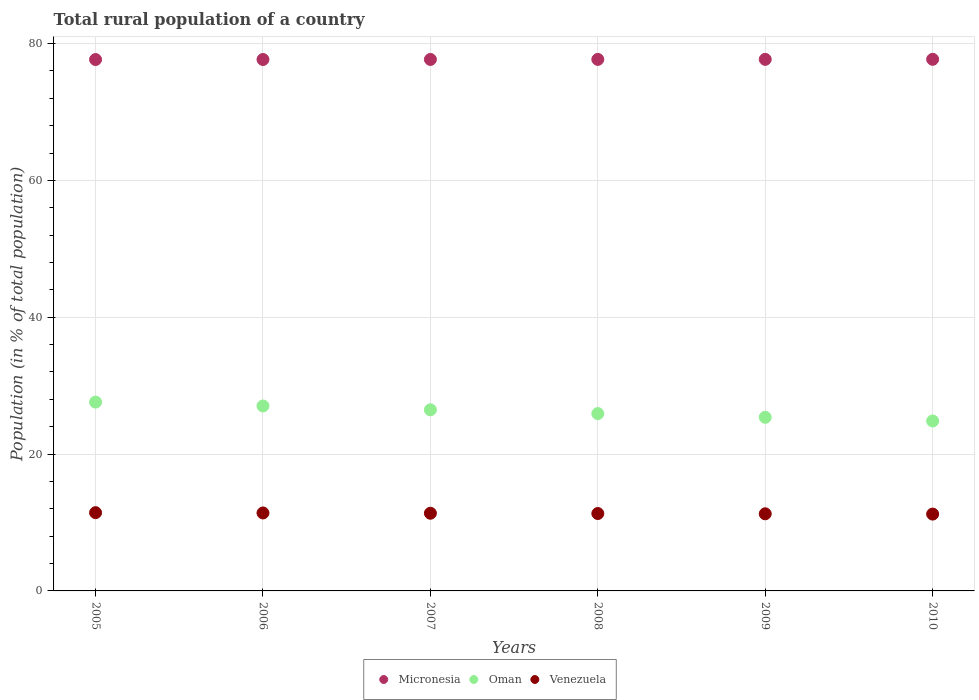How many different coloured dotlines are there?
Give a very brief answer. 3. What is the rural population in Micronesia in 2005?
Provide a succinct answer. 77.67. Across all years, what is the maximum rural population in Micronesia?
Provide a short and direct response. 77.7. Across all years, what is the minimum rural population in Venezuela?
Provide a succinct answer. 11.23. In which year was the rural population in Oman maximum?
Offer a terse response. 2005. In which year was the rural population in Venezuela minimum?
Give a very brief answer. 2010. What is the total rural population in Micronesia in the graph?
Give a very brief answer. 466.11. What is the difference between the rural population in Micronesia in 2005 and that in 2006?
Make the answer very short. -0.01. What is the difference between the rural population in Micronesia in 2007 and the rural population in Oman in 2010?
Keep it short and to the point. 52.84. What is the average rural population in Oman per year?
Your answer should be very brief. 26.21. In the year 2005, what is the difference between the rural population in Micronesia and rural population in Venezuela?
Offer a terse response. 66.23. What is the ratio of the rural population in Venezuela in 2006 to that in 2009?
Provide a short and direct response. 1.01. Is the rural population in Oman in 2007 less than that in 2009?
Your response must be concise. No. Is the difference between the rural population in Micronesia in 2005 and 2007 greater than the difference between the rural population in Venezuela in 2005 and 2007?
Make the answer very short. No. What is the difference between the highest and the second highest rural population in Micronesia?
Ensure brevity in your answer.  0.01. What is the difference between the highest and the lowest rural population in Venezuela?
Ensure brevity in your answer.  0.21. In how many years, is the rural population in Micronesia greater than the average rural population in Micronesia taken over all years?
Provide a succinct answer. 3. Is the sum of the rural population in Oman in 2005 and 2009 greater than the maximum rural population in Micronesia across all years?
Offer a very short reply. No. Does the rural population in Oman monotonically increase over the years?
Your answer should be very brief. No. Is the rural population in Micronesia strictly less than the rural population in Oman over the years?
Your answer should be compact. No. What is the difference between two consecutive major ticks on the Y-axis?
Offer a very short reply. 20. Does the graph contain any zero values?
Give a very brief answer. No. Does the graph contain grids?
Ensure brevity in your answer.  Yes. Where does the legend appear in the graph?
Your response must be concise. Bottom center. How many legend labels are there?
Keep it short and to the point. 3. What is the title of the graph?
Offer a terse response. Total rural population of a country. Does "Papua New Guinea" appear as one of the legend labels in the graph?
Your answer should be very brief. No. What is the label or title of the X-axis?
Your answer should be very brief. Years. What is the label or title of the Y-axis?
Your answer should be very brief. Population (in % of total population). What is the Population (in % of total population) in Micronesia in 2005?
Your answer should be very brief. 77.67. What is the Population (in % of total population) in Oman in 2005?
Make the answer very short. 27.6. What is the Population (in % of total population) of Venezuela in 2005?
Provide a short and direct response. 11.44. What is the Population (in % of total population) in Micronesia in 2006?
Offer a terse response. 77.68. What is the Population (in % of total population) of Oman in 2006?
Your answer should be very brief. 27.03. What is the Population (in % of total population) in Venezuela in 2006?
Your response must be concise. 11.39. What is the Population (in % of total population) in Micronesia in 2007?
Give a very brief answer. 77.68. What is the Population (in % of total population) in Oman in 2007?
Offer a very short reply. 26.47. What is the Population (in % of total population) of Venezuela in 2007?
Give a very brief answer. 11.35. What is the Population (in % of total population) of Micronesia in 2008?
Your response must be concise. 77.69. What is the Population (in % of total population) of Oman in 2008?
Your answer should be very brief. 25.92. What is the Population (in % of total population) in Venezuela in 2008?
Your answer should be compact. 11.31. What is the Population (in % of total population) in Micronesia in 2009?
Provide a short and direct response. 77.69. What is the Population (in % of total population) in Oman in 2009?
Keep it short and to the point. 25.38. What is the Population (in % of total population) in Venezuela in 2009?
Ensure brevity in your answer.  11.27. What is the Population (in % of total population) in Micronesia in 2010?
Your response must be concise. 77.7. What is the Population (in % of total population) of Oman in 2010?
Give a very brief answer. 24.84. What is the Population (in % of total population) of Venezuela in 2010?
Provide a short and direct response. 11.23. Across all years, what is the maximum Population (in % of total population) of Micronesia?
Offer a terse response. 77.7. Across all years, what is the maximum Population (in % of total population) of Oman?
Ensure brevity in your answer.  27.6. Across all years, what is the maximum Population (in % of total population) in Venezuela?
Provide a succinct answer. 11.44. Across all years, what is the minimum Population (in % of total population) of Micronesia?
Your response must be concise. 77.67. Across all years, what is the minimum Population (in % of total population) of Oman?
Provide a succinct answer. 24.84. Across all years, what is the minimum Population (in % of total population) in Venezuela?
Offer a very short reply. 11.23. What is the total Population (in % of total population) in Micronesia in the graph?
Ensure brevity in your answer.  466.12. What is the total Population (in % of total population) in Oman in the graph?
Offer a terse response. 157.24. What is the total Population (in % of total population) in Venezuela in the graph?
Your response must be concise. 68. What is the difference between the Population (in % of total population) in Micronesia in 2005 and that in 2006?
Provide a succinct answer. -0.01. What is the difference between the Population (in % of total population) of Oman in 2005 and that in 2006?
Offer a terse response. 0.57. What is the difference between the Population (in % of total population) in Venezuela in 2005 and that in 2006?
Give a very brief answer. 0.04. What is the difference between the Population (in % of total population) in Micronesia in 2005 and that in 2007?
Ensure brevity in your answer.  -0.01. What is the difference between the Population (in % of total population) of Oman in 2005 and that in 2007?
Keep it short and to the point. 1.13. What is the difference between the Population (in % of total population) of Venezuela in 2005 and that in 2007?
Your response must be concise. 0.08. What is the difference between the Population (in % of total population) in Micronesia in 2005 and that in 2008?
Offer a terse response. -0.02. What is the difference between the Population (in % of total population) of Oman in 2005 and that in 2008?
Offer a terse response. 1.68. What is the difference between the Population (in % of total population) in Venezuela in 2005 and that in 2008?
Provide a short and direct response. 0.12. What is the difference between the Population (in % of total population) in Micronesia in 2005 and that in 2009?
Ensure brevity in your answer.  -0.03. What is the difference between the Population (in % of total population) of Oman in 2005 and that in 2009?
Ensure brevity in your answer.  2.22. What is the difference between the Population (in % of total population) in Venezuela in 2005 and that in 2009?
Make the answer very short. 0.17. What is the difference between the Population (in % of total population) in Micronesia in 2005 and that in 2010?
Provide a succinct answer. -0.03. What is the difference between the Population (in % of total population) in Oman in 2005 and that in 2010?
Your answer should be very brief. 2.76. What is the difference between the Population (in % of total population) in Venezuela in 2005 and that in 2010?
Ensure brevity in your answer.  0.21. What is the difference between the Population (in % of total population) in Micronesia in 2006 and that in 2007?
Provide a short and direct response. -0.01. What is the difference between the Population (in % of total population) of Oman in 2006 and that in 2007?
Provide a succinct answer. 0.56. What is the difference between the Population (in % of total population) of Venezuela in 2006 and that in 2007?
Offer a terse response. 0.04. What is the difference between the Population (in % of total population) of Micronesia in 2006 and that in 2008?
Your answer should be compact. -0.01. What is the difference between the Population (in % of total population) in Oman in 2006 and that in 2008?
Give a very brief answer. 1.11. What is the difference between the Population (in % of total population) of Venezuela in 2006 and that in 2008?
Give a very brief answer. 0.08. What is the difference between the Population (in % of total population) in Micronesia in 2006 and that in 2009?
Offer a terse response. -0.02. What is the difference between the Population (in % of total population) of Oman in 2006 and that in 2009?
Offer a very short reply. 1.66. What is the difference between the Population (in % of total population) of Venezuela in 2006 and that in 2009?
Your answer should be very brief. 0.12. What is the difference between the Population (in % of total population) in Micronesia in 2006 and that in 2010?
Give a very brief answer. -0.03. What is the difference between the Population (in % of total population) of Oman in 2006 and that in 2010?
Make the answer very short. 2.19. What is the difference between the Population (in % of total population) in Venezuela in 2006 and that in 2010?
Your answer should be compact. 0.16. What is the difference between the Population (in % of total population) in Micronesia in 2007 and that in 2008?
Your response must be concise. -0.01. What is the difference between the Population (in % of total population) of Oman in 2007 and that in 2008?
Offer a very short reply. 0.55. What is the difference between the Population (in % of total population) of Venezuela in 2007 and that in 2008?
Your response must be concise. 0.04. What is the difference between the Population (in % of total population) in Micronesia in 2007 and that in 2009?
Your answer should be very brief. -0.01. What is the difference between the Population (in % of total population) in Oman in 2007 and that in 2009?
Your answer should be compact. 1.1. What is the difference between the Population (in % of total population) in Venezuela in 2007 and that in 2009?
Your response must be concise. 0.08. What is the difference between the Population (in % of total population) of Micronesia in 2007 and that in 2010?
Your response must be concise. -0.02. What is the difference between the Population (in % of total population) of Oman in 2007 and that in 2010?
Keep it short and to the point. 1.63. What is the difference between the Population (in % of total population) of Venezuela in 2007 and that in 2010?
Make the answer very short. 0.12. What is the difference between the Population (in % of total population) of Micronesia in 2008 and that in 2009?
Your response must be concise. -0.01. What is the difference between the Population (in % of total population) of Oman in 2008 and that in 2009?
Offer a very short reply. 0.54. What is the difference between the Population (in % of total population) of Venezuela in 2008 and that in 2009?
Provide a succinct answer. 0.04. What is the difference between the Population (in % of total population) of Micronesia in 2008 and that in 2010?
Provide a short and direct response. -0.01. What is the difference between the Population (in % of total population) of Oman in 2008 and that in 2010?
Keep it short and to the point. 1.08. What is the difference between the Population (in % of total population) in Venezuela in 2008 and that in 2010?
Offer a terse response. 0.08. What is the difference between the Population (in % of total population) in Micronesia in 2009 and that in 2010?
Your answer should be very brief. -0.01. What is the difference between the Population (in % of total population) of Oman in 2009 and that in 2010?
Make the answer very short. 0.54. What is the difference between the Population (in % of total population) in Venezuela in 2009 and that in 2010?
Your response must be concise. 0.04. What is the difference between the Population (in % of total population) in Micronesia in 2005 and the Population (in % of total population) in Oman in 2006?
Provide a succinct answer. 50.64. What is the difference between the Population (in % of total population) of Micronesia in 2005 and the Population (in % of total population) of Venezuela in 2006?
Give a very brief answer. 66.28. What is the difference between the Population (in % of total population) of Oman in 2005 and the Population (in % of total population) of Venezuela in 2006?
Your response must be concise. 16.2. What is the difference between the Population (in % of total population) in Micronesia in 2005 and the Population (in % of total population) in Oman in 2007?
Your answer should be very brief. 51.2. What is the difference between the Population (in % of total population) in Micronesia in 2005 and the Population (in % of total population) in Venezuela in 2007?
Ensure brevity in your answer.  66.32. What is the difference between the Population (in % of total population) in Oman in 2005 and the Population (in % of total population) in Venezuela in 2007?
Your answer should be compact. 16.25. What is the difference between the Population (in % of total population) in Micronesia in 2005 and the Population (in % of total population) in Oman in 2008?
Offer a very short reply. 51.75. What is the difference between the Population (in % of total population) of Micronesia in 2005 and the Population (in % of total population) of Venezuela in 2008?
Offer a very short reply. 66.36. What is the difference between the Population (in % of total population) in Oman in 2005 and the Population (in % of total population) in Venezuela in 2008?
Give a very brief answer. 16.29. What is the difference between the Population (in % of total population) of Micronesia in 2005 and the Population (in % of total population) of Oman in 2009?
Keep it short and to the point. 52.29. What is the difference between the Population (in % of total population) in Micronesia in 2005 and the Population (in % of total population) in Venezuela in 2009?
Your response must be concise. 66.4. What is the difference between the Population (in % of total population) of Oman in 2005 and the Population (in % of total population) of Venezuela in 2009?
Provide a short and direct response. 16.33. What is the difference between the Population (in % of total population) of Micronesia in 2005 and the Population (in % of total population) of Oman in 2010?
Ensure brevity in your answer.  52.83. What is the difference between the Population (in % of total population) of Micronesia in 2005 and the Population (in % of total population) of Venezuela in 2010?
Give a very brief answer. 66.44. What is the difference between the Population (in % of total population) in Oman in 2005 and the Population (in % of total population) in Venezuela in 2010?
Provide a succinct answer. 16.37. What is the difference between the Population (in % of total population) in Micronesia in 2006 and the Population (in % of total population) in Oman in 2007?
Give a very brief answer. 51.2. What is the difference between the Population (in % of total population) in Micronesia in 2006 and the Population (in % of total population) in Venezuela in 2007?
Give a very brief answer. 66.32. What is the difference between the Population (in % of total population) in Oman in 2006 and the Population (in % of total population) in Venezuela in 2007?
Provide a succinct answer. 15.68. What is the difference between the Population (in % of total population) of Micronesia in 2006 and the Population (in % of total population) of Oman in 2008?
Your answer should be compact. 51.76. What is the difference between the Population (in % of total population) of Micronesia in 2006 and the Population (in % of total population) of Venezuela in 2008?
Your response must be concise. 66.36. What is the difference between the Population (in % of total population) of Oman in 2006 and the Population (in % of total population) of Venezuela in 2008?
Offer a terse response. 15.72. What is the difference between the Population (in % of total population) of Micronesia in 2006 and the Population (in % of total population) of Oman in 2009?
Make the answer very short. 52.3. What is the difference between the Population (in % of total population) of Micronesia in 2006 and the Population (in % of total population) of Venezuela in 2009?
Give a very brief answer. 66.4. What is the difference between the Population (in % of total population) of Oman in 2006 and the Population (in % of total population) of Venezuela in 2009?
Provide a short and direct response. 15.76. What is the difference between the Population (in % of total population) of Micronesia in 2006 and the Population (in % of total population) of Oman in 2010?
Offer a terse response. 52.84. What is the difference between the Population (in % of total population) in Micronesia in 2006 and the Population (in % of total population) in Venezuela in 2010?
Ensure brevity in your answer.  66.44. What is the difference between the Population (in % of total population) of Oman in 2006 and the Population (in % of total population) of Venezuela in 2010?
Your response must be concise. 15.8. What is the difference between the Population (in % of total population) of Micronesia in 2007 and the Population (in % of total population) of Oman in 2008?
Offer a terse response. 51.76. What is the difference between the Population (in % of total population) of Micronesia in 2007 and the Population (in % of total population) of Venezuela in 2008?
Offer a terse response. 66.37. What is the difference between the Population (in % of total population) of Oman in 2007 and the Population (in % of total population) of Venezuela in 2008?
Make the answer very short. 15.16. What is the difference between the Population (in % of total population) of Micronesia in 2007 and the Population (in % of total population) of Oman in 2009?
Provide a succinct answer. 52.31. What is the difference between the Population (in % of total population) in Micronesia in 2007 and the Population (in % of total population) in Venezuela in 2009?
Your response must be concise. 66.41. What is the difference between the Population (in % of total population) of Oman in 2007 and the Population (in % of total population) of Venezuela in 2009?
Offer a very short reply. 15.2. What is the difference between the Population (in % of total population) in Micronesia in 2007 and the Population (in % of total population) in Oman in 2010?
Your answer should be compact. 52.84. What is the difference between the Population (in % of total population) in Micronesia in 2007 and the Population (in % of total population) in Venezuela in 2010?
Provide a short and direct response. 66.45. What is the difference between the Population (in % of total population) of Oman in 2007 and the Population (in % of total population) of Venezuela in 2010?
Your answer should be very brief. 15.24. What is the difference between the Population (in % of total population) in Micronesia in 2008 and the Population (in % of total population) in Oman in 2009?
Your answer should be compact. 52.31. What is the difference between the Population (in % of total population) in Micronesia in 2008 and the Population (in % of total population) in Venezuela in 2009?
Offer a very short reply. 66.42. What is the difference between the Population (in % of total population) in Oman in 2008 and the Population (in % of total population) in Venezuela in 2009?
Ensure brevity in your answer.  14.65. What is the difference between the Population (in % of total population) in Micronesia in 2008 and the Population (in % of total population) in Oman in 2010?
Give a very brief answer. 52.85. What is the difference between the Population (in % of total population) in Micronesia in 2008 and the Population (in % of total population) in Venezuela in 2010?
Your answer should be very brief. 66.46. What is the difference between the Population (in % of total population) of Oman in 2008 and the Population (in % of total population) of Venezuela in 2010?
Your answer should be compact. 14.69. What is the difference between the Population (in % of total population) of Micronesia in 2009 and the Population (in % of total population) of Oman in 2010?
Provide a succinct answer. 52.86. What is the difference between the Population (in % of total population) of Micronesia in 2009 and the Population (in % of total population) of Venezuela in 2010?
Ensure brevity in your answer.  66.46. What is the difference between the Population (in % of total population) of Oman in 2009 and the Population (in % of total population) of Venezuela in 2010?
Your answer should be very brief. 14.14. What is the average Population (in % of total population) of Micronesia per year?
Your response must be concise. 77.69. What is the average Population (in % of total population) in Oman per year?
Keep it short and to the point. 26.21. What is the average Population (in % of total population) in Venezuela per year?
Make the answer very short. 11.33. In the year 2005, what is the difference between the Population (in % of total population) of Micronesia and Population (in % of total population) of Oman?
Your answer should be very brief. 50.07. In the year 2005, what is the difference between the Population (in % of total population) in Micronesia and Population (in % of total population) in Venezuela?
Your answer should be very brief. 66.23. In the year 2005, what is the difference between the Population (in % of total population) of Oman and Population (in % of total population) of Venezuela?
Your response must be concise. 16.16. In the year 2006, what is the difference between the Population (in % of total population) in Micronesia and Population (in % of total population) in Oman?
Your answer should be compact. 50.64. In the year 2006, what is the difference between the Population (in % of total population) of Micronesia and Population (in % of total population) of Venezuela?
Your answer should be very brief. 66.28. In the year 2006, what is the difference between the Population (in % of total population) in Oman and Population (in % of total population) in Venezuela?
Provide a succinct answer. 15.64. In the year 2007, what is the difference between the Population (in % of total population) in Micronesia and Population (in % of total population) in Oman?
Keep it short and to the point. 51.21. In the year 2007, what is the difference between the Population (in % of total population) in Micronesia and Population (in % of total population) in Venezuela?
Make the answer very short. 66.33. In the year 2007, what is the difference between the Population (in % of total population) in Oman and Population (in % of total population) in Venezuela?
Your answer should be compact. 15.12. In the year 2008, what is the difference between the Population (in % of total population) in Micronesia and Population (in % of total population) in Oman?
Give a very brief answer. 51.77. In the year 2008, what is the difference between the Population (in % of total population) of Micronesia and Population (in % of total population) of Venezuela?
Give a very brief answer. 66.38. In the year 2008, what is the difference between the Population (in % of total population) in Oman and Population (in % of total population) in Venezuela?
Keep it short and to the point. 14.61. In the year 2009, what is the difference between the Population (in % of total population) of Micronesia and Population (in % of total population) of Oman?
Your response must be concise. 52.32. In the year 2009, what is the difference between the Population (in % of total population) in Micronesia and Population (in % of total population) in Venezuela?
Provide a succinct answer. 66.42. In the year 2009, what is the difference between the Population (in % of total population) of Oman and Population (in % of total population) of Venezuela?
Your answer should be compact. 14.1. In the year 2010, what is the difference between the Population (in % of total population) of Micronesia and Population (in % of total population) of Oman?
Your answer should be compact. 52.86. In the year 2010, what is the difference between the Population (in % of total population) in Micronesia and Population (in % of total population) in Venezuela?
Provide a short and direct response. 66.47. In the year 2010, what is the difference between the Population (in % of total population) of Oman and Population (in % of total population) of Venezuela?
Provide a succinct answer. 13.61. What is the ratio of the Population (in % of total population) of Micronesia in 2005 to that in 2007?
Give a very brief answer. 1. What is the ratio of the Population (in % of total population) of Oman in 2005 to that in 2007?
Give a very brief answer. 1.04. What is the ratio of the Population (in % of total population) in Venezuela in 2005 to that in 2007?
Ensure brevity in your answer.  1.01. What is the ratio of the Population (in % of total population) in Oman in 2005 to that in 2008?
Provide a short and direct response. 1.06. What is the ratio of the Population (in % of total population) in Venezuela in 2005 to that in 2008?
Your response must be concise. 1.01. What is the ratio of the Population (in % of total population) in Micronesia in 2005 to that in 2009?
Keep it short and to the point. 1. What is the ratio of the Population (in % of total population) of Oman in 2005 to that in 2009?
Your answer should be very brief. 1.09. What is the ratio of the Population (in % of total population) of Venezuela in 2005 to that in 2009?
Offer a very short reply. 1.01. What is the ratio of the Population (in % of total population) of Micronesia in 2005 to that in 2010?
Ensure brevity in your answer.  1. What is the ratio of the Population (in % of total population) in Oman in 2005 to that in 2010?
Your answer should be compact. 1.11. What is the ratio of the Population (in % of total population) in Venezuela in 2005 to that in 2010?
Your response must be concise. 1.02. What is the ratio of the Population (in % of total population) of Oman in 2006 to that in 2007?
Offer a very short reply. 1.02. What is the ratio of the Population (in % of total population) of Venezuela in 2006 to that in 2007?
Your response must be concise. 1. What is the ratio of the Population (in % of total population) in Micronesia in 2006 to that in 2008?
Make the answer very short. 1. What is the ratio of the Population (in % of total population) of Oman in 2006 to that in 2008?
Provide a short and direct response. 1.04. What is the ratio of the Population (in % of total population) in Oman in 2006 to that in 2009?
Give a very brief answer. 1.07. What is the ratio of the Population (in % of total population) of Venezuela in 2006 to that in 2009?
Give a very brief answer. 1.01. What is the ratio of the Population (in % of total population) of Oman in 2006 to that in 2010?
Your answer should be very brief. 1.09. What is the ratio of the Population (in % of total population) in Venezuela in 2006 to that in 2010?
Make the answer very short. 1.01. What is the ratio of the Population (in % of total population) of Micronesia in 2007 to that in 2008?
Your response must be concise. 1. What is the ratio of the Population (in % of total population) in Oman in 2007 to that in 2008?
Provide a succinct answer. 1.02. What is the ratio of the Population (in % of total population) of Micronesia in 2007 to that in 2009?
Provide a short and direct response. 1. What is the ratio of the Population (in % of total population) of Oman in 2007 to that in 2009?
Make the answer very short. 1.04. What is the ratio of the Population (in % of total population) of Venezuela in 2007 to that in 2009?
Ensure brevity in your answer.  1.01. What is the ratio of the Population (in % of total population) in Micronesia in 2007 to that in 2010?
Your response must be concise. 1. What is the ratio of the Population (in % of total population) of Oman in 2007 to that in 2010?
Keep it short and to the point. 1.07. What is the ratio of the Population (in % of total population) in Oman in 2008 to that in 2009?
Give a very brief answer. 1.02. What is the ratio of the Population (in % of total population) of Venezuela in 2008 to that in 2009?
Your response must be concise. 1. What is the ratio of the Population (in % of total population) in Oman in 2008 to that in 2010?
Provide a short and direct response. 1.04. What is the ratio of the Population (in % of total population) in Venezuela in 2008 to that in 2010?
Offer a very short reply. 1.01. What is the ratio of the Population (in % of total population) of Micronesia in 2009 to that in 2010?
Provide a short and direct response. 1. What is the ratio of the Population (in % of total population) of Oman in 2009 to that in 2010?
Ensure brevity in your answer.  1.02. What is the ratio of the Population (in % of total population) in Venezuela in 2009 to that in 2010?
Keep it short and to the point. 1. What is the difference between the highest and the second highest Population (in % of total population) in Micronesia?
Offer a very short reply. 0.01. What is the difference between the highest and the second highest Population (in % of total population) in Oman?
Your answer should be compact. 0.57. What is the difference between the highest and the second highest Population (in % of total population) in Venezuela?
Keep it short and to the point. 0.04. What is the difference between the highest and the lowest Population (in % of total population) of Micronesia?
Offer a terse response. 0.03. What is the difference between the highest and the lowest Population (in % of total population) in Oman?
Give a very brief answer. 2.76. What is the difference between the highest and the lowest Population (in % of total population) of Venezuela?
Offer a terse response. 0.21. 